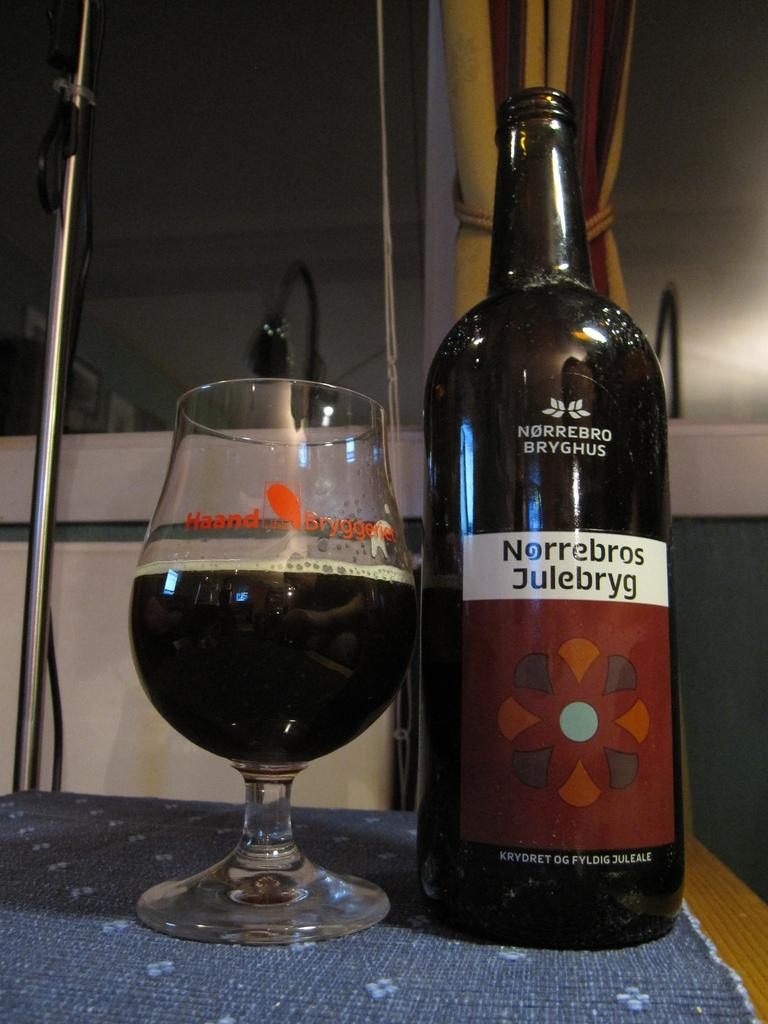<image>
Share a concise interpretation of the image provided. An open bottle of Norrebros Jullebryg along with a half full glass. 